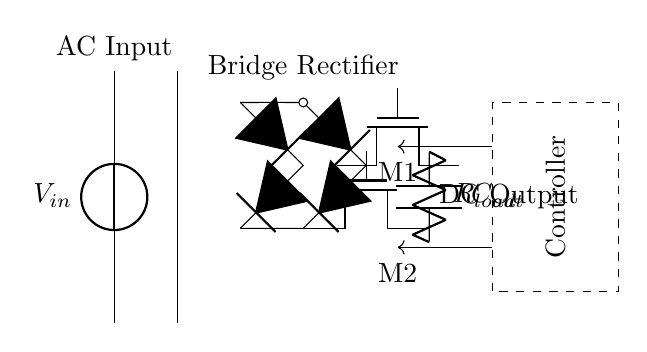What is the input type of this circuit? The input type is AC, as indicated by the label on the voltage source marked \( V_{in} \).
Answer: AC What are the two main components used for rectification? The two main components for rectification are the bridge rectifier and the synchronous MOSFETs, labeled as D* and Tnmos respectively in the diagram.
Answer: Bridge rectifier and synchronous MOSFETs How many MOSFETs are present in the circuit? There are two MOSFETs present in the circuit, labeled M1 and M2 at their respective positions.
Answer: Two What is the purpose of the output capacitor? The output capacitor, labeled \( C_{out} \), is used to smooth the DC output voltage by reducing ripple.
Answer: To smooth DC output Why is a controller included in the circuit? The controller is included to manage the switching of the synchronous MOSFETs, to enhance efficiency by reducing losses during rectification.
Answer: To manage synchronous MOSFET switching What does the dashed rectangle represent? The dashed rectangle represents the controller, which is responsible for regulating the operation of the MOSFETs and improving efficiency in the rectification process.
Answer: The controller What are the labels on the load in this circuit? The load is labeled as \( R_{load} \) in the circuit diagram. It indicates the resistance connected to the output.
Answer: R load 